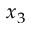<formula> <loc_0><loc_0><loc_500><loc_500>x _ { 3 }</formula> 